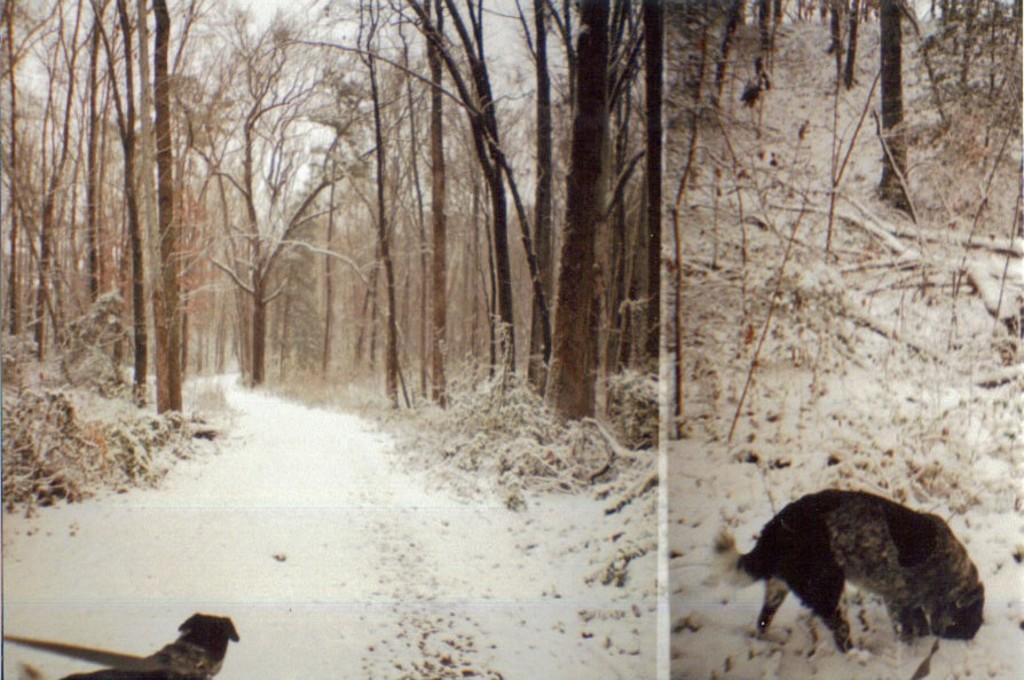What type of artwork is the image? The image is a collage. What animal is featured in the image? There is a dog in the image. What weather condition is depicted in the image? The image depicts snow. What type of natural scenery can be seen in the background of the image? There are trees in the background of the image. What part of the natural environment is visible in the background of the image? The sky is visible in the background of the image. What type of music does the band play in the image? There is no band present in the image, so it is not possible to determine what type of music they might play. 